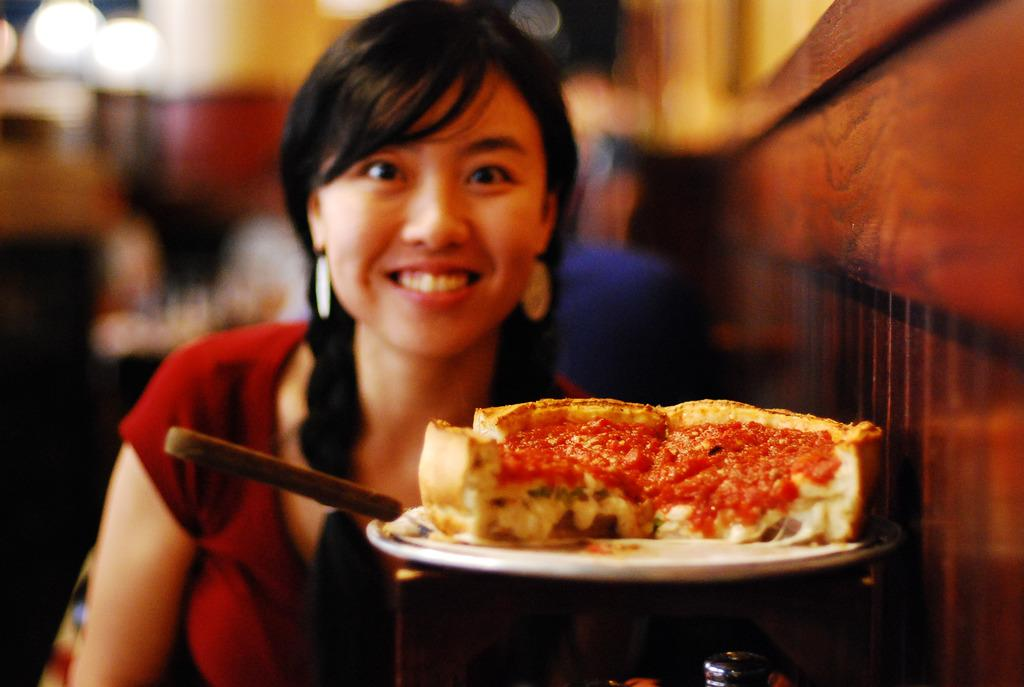Who is present in the image? There is a woman in the image. What is the woman doing in the image? The woman is smiling in the image. What is on the table in front of the woman? There is food on a plate in front of the woman. Can you describe the background of the image? The background of the image is blurred. What type of ink is being used in the fight scene depicted in the image? There is no fight scene or ink present in the image; it features a woman smiling with food on a plate in front of her. 